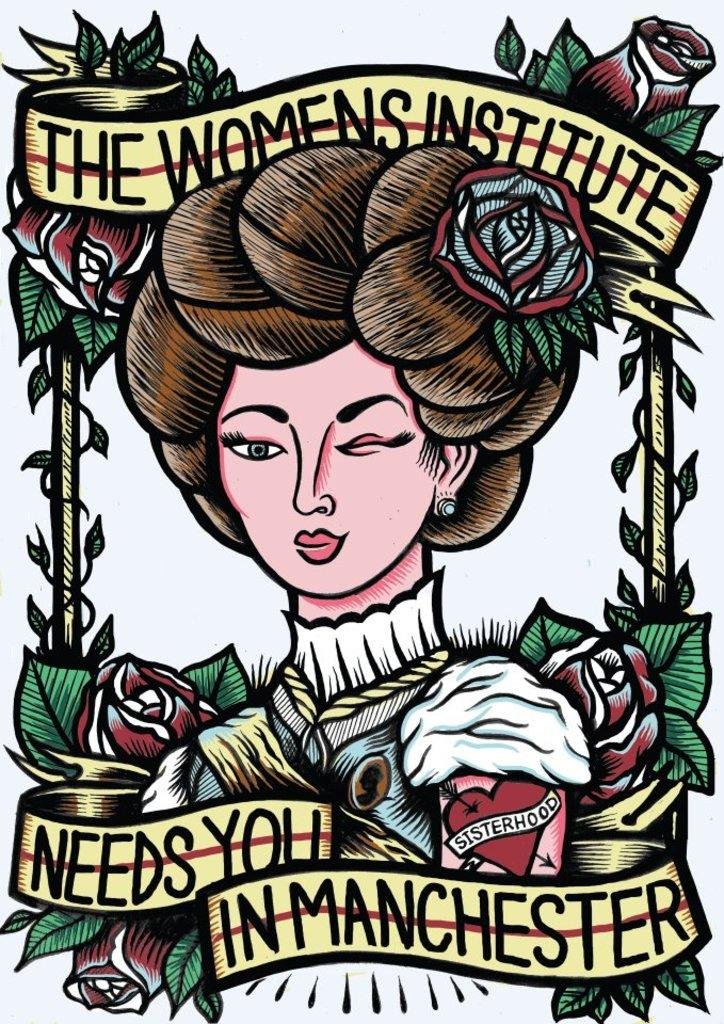What is depicted in the painting in the image? There is a painting of a woman in the image. What other elements are present in the image besides the painting? There are flowers, text at the top, and text at the bottom in the image. How does the card connect to the painting in the image? There is no card present in the image, so it cannot be connected to the painting. 